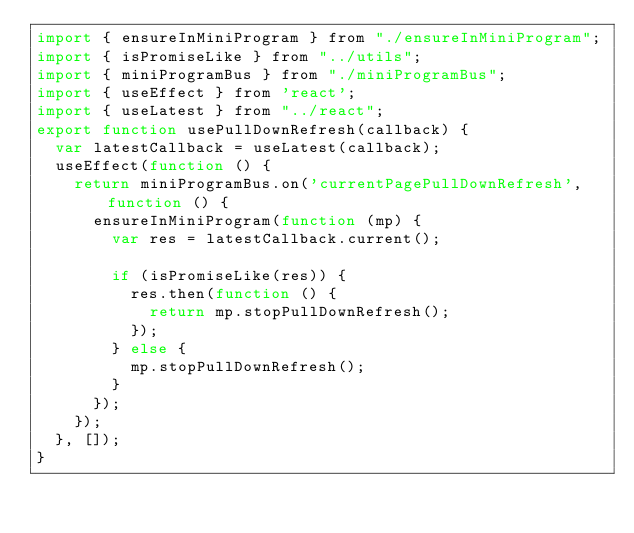Convert code to text. <code><loc_0><loc_0><loc_500><loc_500><_JavaScript_>import { ensureInMiniProgram } from "./ensureInMiniProgram";
import { isPromiseLike } from "../utils";
import { miniProgramBus } from "./miniProgramBus";
import { useEffect } from 'react';
import { useLatest } from "../react";
export function usePullDownRefresh(callback) {
  var latestCallback = useLatest(callback);
  useEffect(function () {
    return miniProgramBus.on('currentPagePullDownRefresh', function () {
      ensureInMiniProgram(function (mp) {
        var res = latestCallback.current();

        if (isPromiseLike(res)) {
          res.then(function () {
            return mp.stopPullDownRefresh();
          });
        } else {
          mp.stopPullDownRefresh();
        }
      });
    });
  }, []);
}</code> 